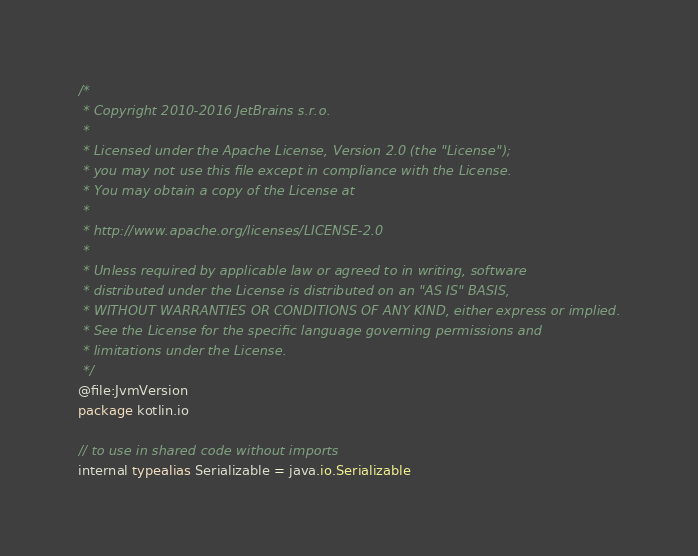Convert code to text. <code><loc_0><loc_0><loc_500><loc_500><_Kotlin_>/*
 * Copyright 2010-2016 JetBrains s.r.o.
 *
 * Licensed under the Apache License, Version 2.0 (the "License");
 * you may not use this file except in compliance with the License.
 * You may obtain a copy of the License at
 *
 * http://www.apache.org/licenses/LICENSE-2.0
 *
 * Unless required by applicable law or agreed to in writing, software
 * distributed under the License is distributed on an "AS IS" BASIS,
 * WITHOUT WARRANTIES OR CONDITIONS OF ANY KIND, either express or implied.
 * See the License for the specific language governing permissions and
 * limitations under the License.
 */
@file:JvmVersion
package kotlin.io

// to use in shared code without imports
internal typealias Serializable = java.io.Serializable</code> 